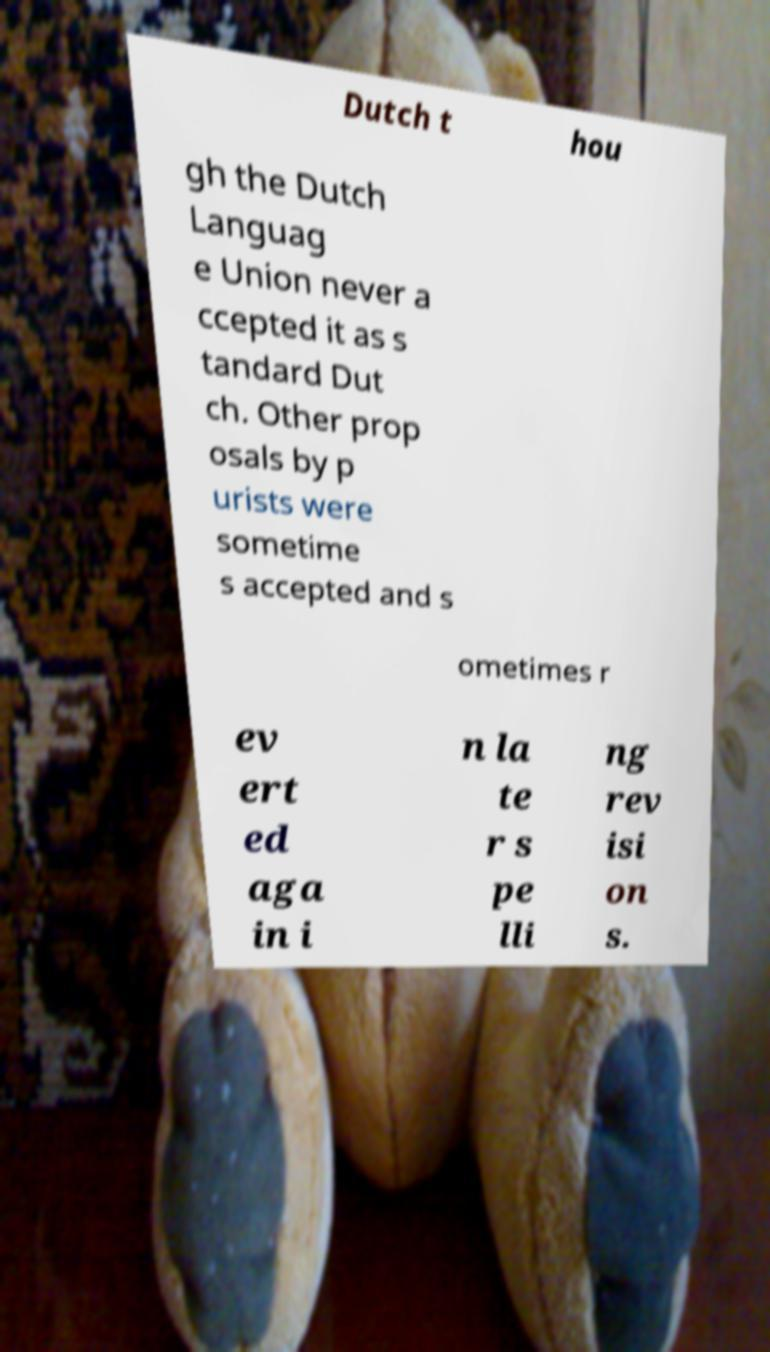Please identify and transcribe the text found in this image. Dutch t hou gh the Dutch Languag e Union never a ccepted it as s tandard Dut ch. Other prop osals by p urists were sometime s accepted and s ometimes r ev ert ed aga in i n la te r s pe lli ng rev isi on s. 